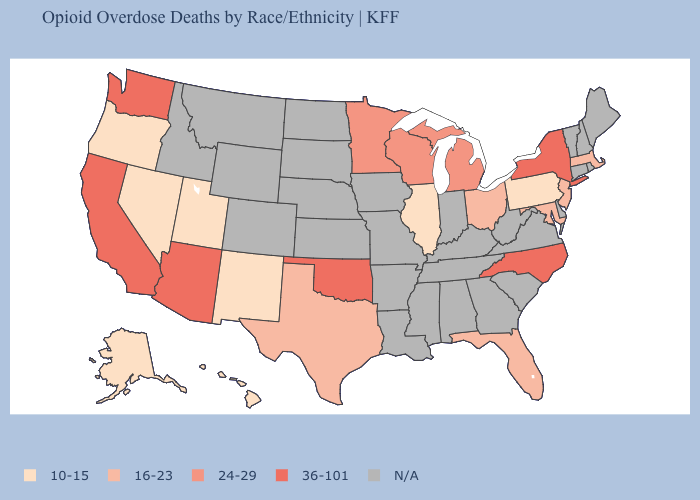Does Maryland have the lowest value in the South?
Answer briefly. Yes. What is the value of New Hampshire?
Short answer required. N/A. What is the value of South Dakota?
Short answer required. N/A. What is the value of Montana?
Give a very brief answer. N/A. Name the states that have a value in the range 36-101?
Keep it brief. Arizona, California, New York, North Carolina, Oklahoma, Washington. Name the states that have a value in the range 36-101?
Write a very short answer. Arizona, California, New York, North Carolina, Oklahoma, Washington. What is the value of Indiana?
Quick response, please. N/A. Name the states that have a value in the range 16-23?
Give a very brief answer. Florida, Maryland, Massachusetts, New Jersey, Ohio, Texas. Among the states that border Ohio , which have the lowest value?
Short answer required. Pennsylvania. What is the value of Utah?
Quick response, please. 10-15. Name the states that have a value in the range 10-15?
Answer briefly. Alaska, Hawaii, Illinois, Nevada, New Mexico, Oregon, Pennsylvania, Utah. Name the states that have a value in the range 10-15?
Concise answer only. Alaska, Hawaii, Illinois, Nevada, New Mexico, Oregon, Pennsylvania, Utah. What is the lowest value in the South?
Write a very short answer. 16-23. What is the highest value in states that border Tennessee?
Answer briefly. 36-101. 